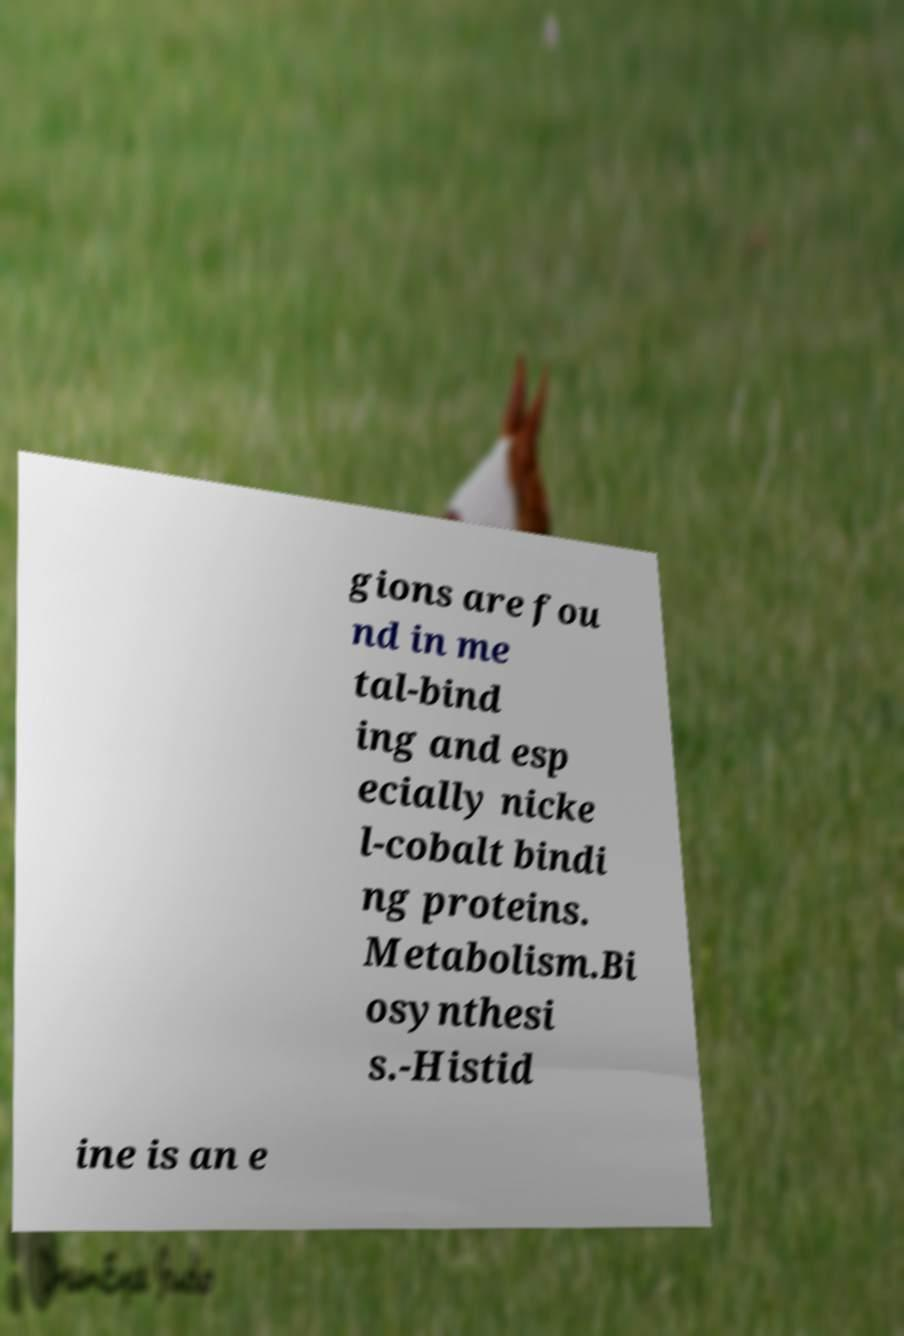Please read and relay the text visible in this image. What does it say? gions are fou nd in me tal-bind ing and esp ecially nicke l-cobalt bindi ng proteins. Metabolism.Bi osynthesi s.-Histid ine is an e 